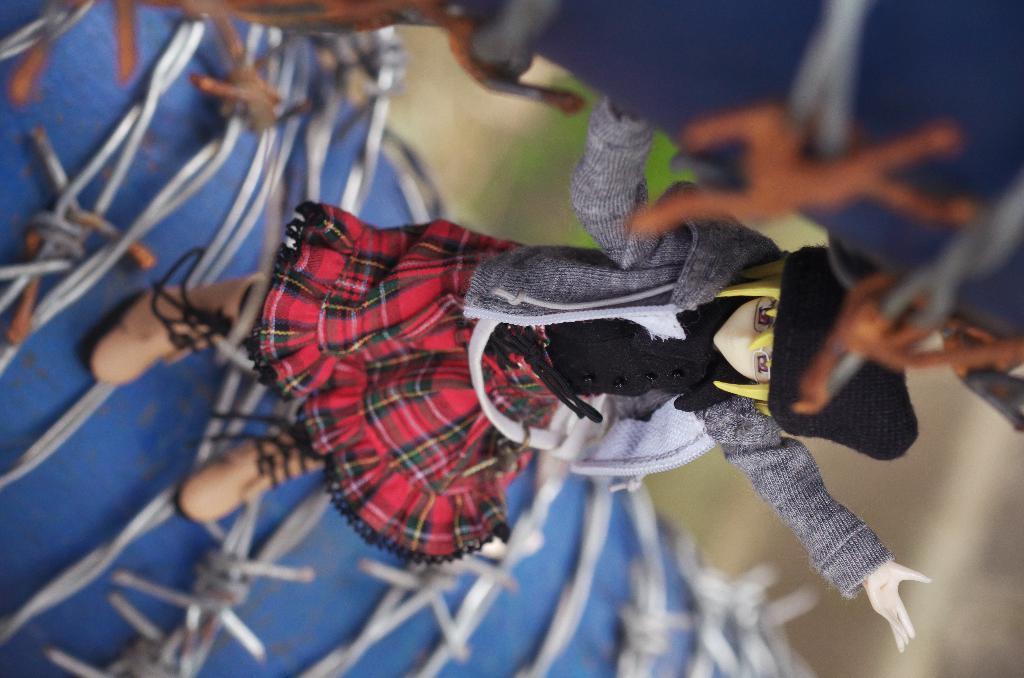In one or two sentences, can you explain what this image depicts? In this image we can see a doll on the blue color object and blur background. 